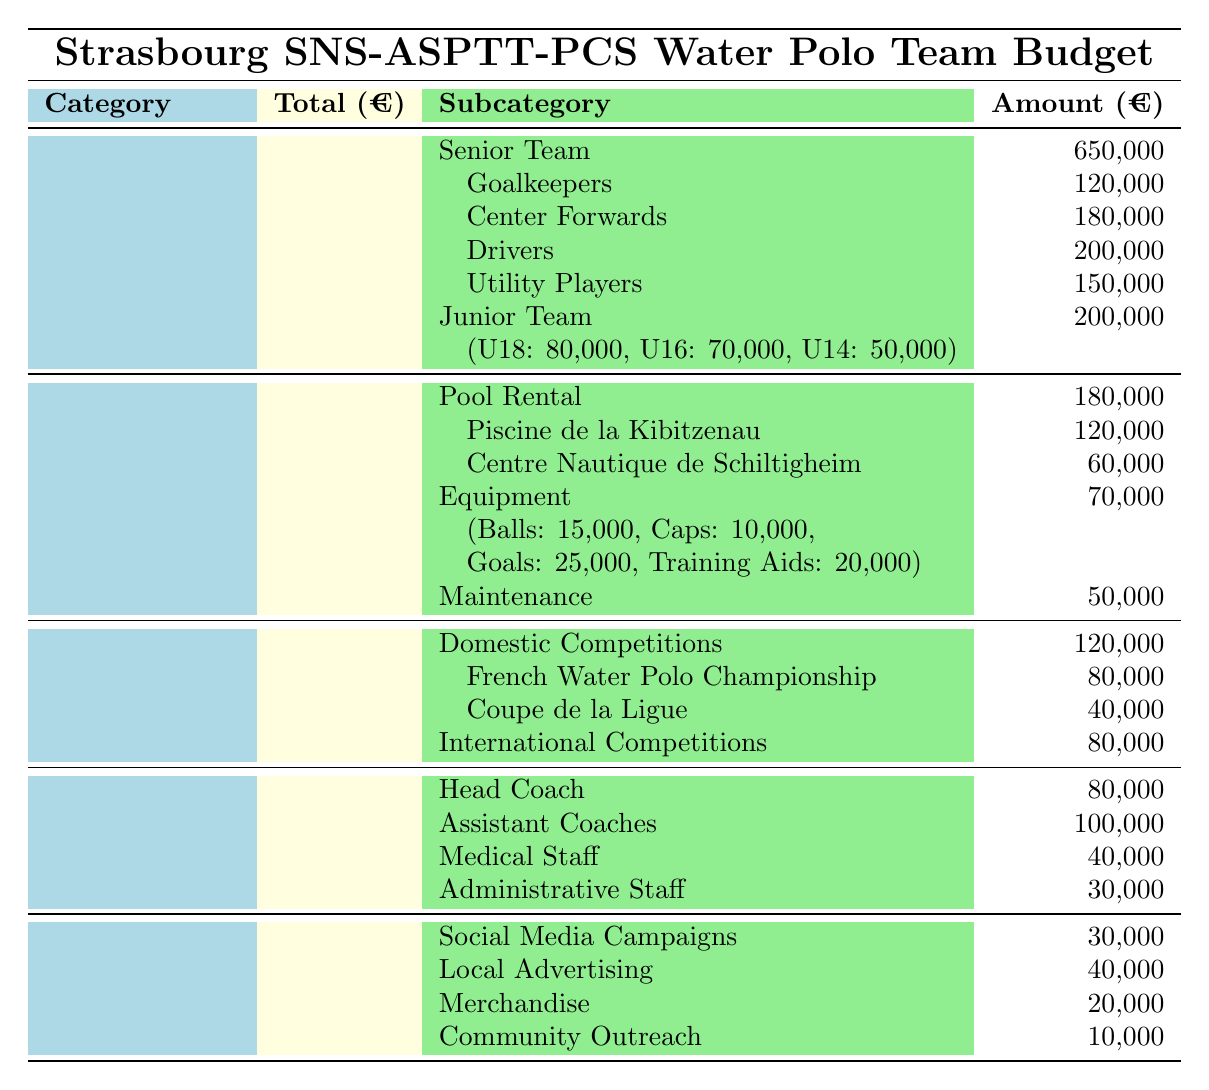What is the total budget allocation for the Strasbourg SNS-ASPTT-PCS Water Polo Team? The total budget allocation is a sum of all the individual categories listed in the table: Player Salaries (850,000), Facilities (300,000), Travel Expenses (200,000), Staff Salaries (250,000), and Marketing and Promotion (100,000). Adding these gives us 850,000 + 300,000 + 200,000 + 250,000 + 100,000 = 1,700,000.
Answer: 1,700,000 How much is allocated to the Senior Team salaries? The Senior Team salaries are specified under the Player Salaries category, with a total amount of 650,000 allocated for that team.
Answer: 650,000 What percentage of the total budget is spent on travel expenses? To find the percentage of travel expenses, we take the total amount for Travel Expenses (200,000) and divide it by the total budget (1,700,000), then multiply by 100. The calculation is (200,000 / 1,700,000) * 100 = 11.76%.
Answer: 11.76% What is the total amount allocated to Player Salaries for the Junior Team? The Junior Team salaries sum up the amounts for the age groups provided: U18 (80,000), U16 (70,000), and U14 (50,000). Therefore, the total for the Junior Team is 80,000 + 70,000 + 50,000 = 200,000.
Answer: 200,000 Is the amount spent on Pool Rental higher than that spent on Equipment? The amount spent on Pool Rental is 180,000, while the amount spent on Equipment is 70,000. Since 180,000 is greater than 70,000, the statement is true.
Answer: Yes Which category has the highest single expenditure item, and what is that amount? To identify the highest single expenditure, we must look through each category and its subcategories. The maximum item is Goalkeepers under Player Salaries at 120,000.
Answer: Player Salaries, 120,000 How much of the budget goes to Domestic Competitions compared to International Competitions? Domestic Competitions account for 120,000 and International Competitions account for 80,000. Comparing these, Domestic Competitions have 40,000 more than International Competitions.
Answer: 40,000 more What is the total cost allocated for marketing and promotion activities? The total for Marketing and Promotion involves adding all listed subcategories: Social Media Campaigns (30,000), Local Advertising (40,000), Merchandise (20,000), and Community Outreach (10,000). This total is 30,000 + 40,000 + 20,000 + 10,000 = 100,000.
Answer: 100,000 Does the total cost of all Player Salaries exceed the total for Facilities? The total for Player Salaries (850,000) is compared to the Facilities budget (300,000). Since 850,000 is greater than 300,000, the answer is yes.
Answer: Yes Which position under Staff Salaries receives the most funding? Among the listed Staff Salaries, Assistant Coaches receive 100,000, which is higher than other positions like Head Coach (80,000), Medical Staff (40,000), and Administrative Staff (30,000). Therefore, the position receiving the most funding is Assistant Coaches.
Answer: Assistant Coaches 